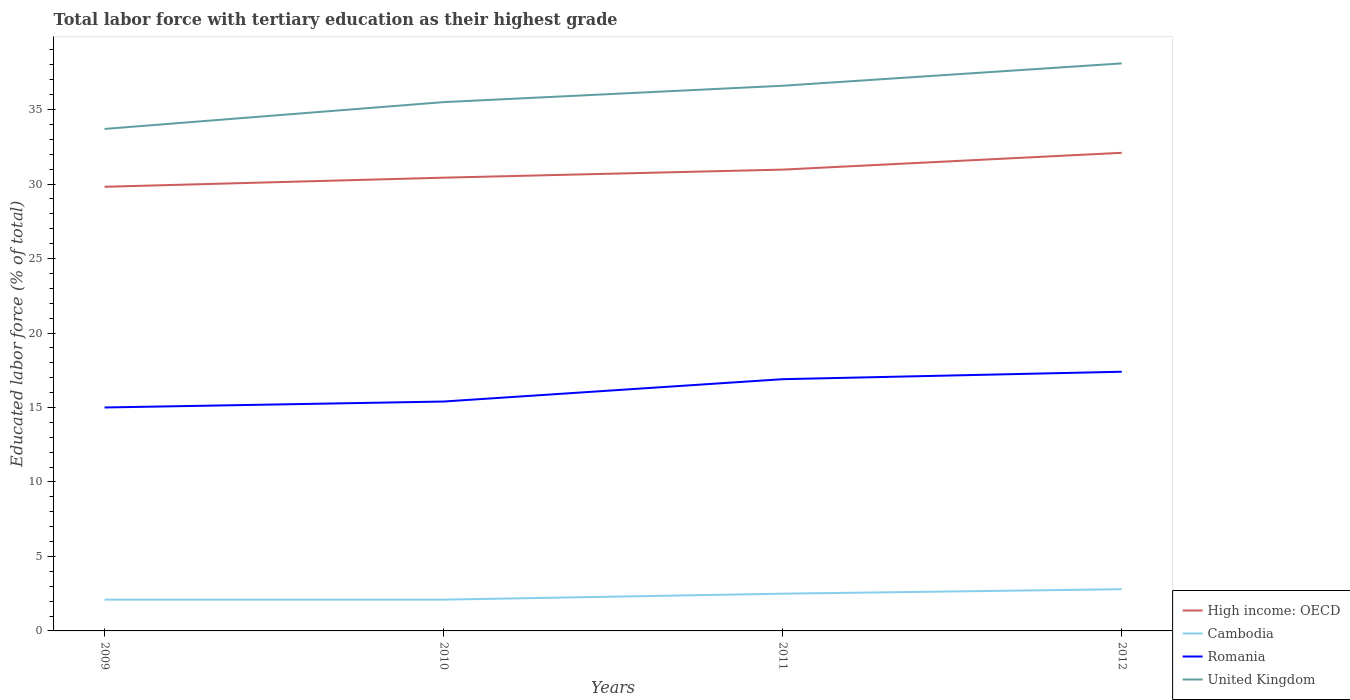Is the number of lines equal to the number of legend labels?
Offer a terse response. Yes. In which year was the percentage of male labor force with tertiary education in Romania maximum?
Your answer should be very brief. 2009. What is the total percentage of male labor force with tertiary education in Romania in the graph?
Your response must be concise. -0.4. What is the difference between the highest and the second highest percentage of male labor force with tertiary education in United Kingdom?
Offer a terse response. 4.4. Is the percentage of male labor force with tertiary education in Romania strictly greater than the percentage of male labor force with tertiary education in High income: OECD over the years?
Your answer should be very brief. Yes. How many years are there in the graph?
Give a very brief answer. 4. Are the values on the major ticks of Y-axis written in scientific E-notation?
Ensure brevity in your answer.  No. Does the graph contain any zero values?
Keep it short and to the point. No. Does the graph contain grids?
Offer a very short reply. No. What is the title of the graph?
Your response must be concise. Total labor force with tertiary education as their highest grade. What is the label or title of the X-axis?
Give a very brief answer. Years. What is the label or title of the Y-axis?
Offer a terse response. Educated labor force (% of total). What is the Educated labor force (% of total) of High income: OECD in 2009?
Make the answer very short. 29.82. What is the Educated labor force (% of total) in Cambodia in 2009?
Your answer should be compact. 2.1. What is the Educated labor force (% of total) of United Kingdom in 2009?
Ensure brevity in your answer.  33.7. What is the Educated labor force (% of total) of High income: OECD in 2010?
Give a very brief answer. 30.43. What is the Educated labor force (% of total) in Cambodia in 2010?
Provide a succinct answer. 2.1. What is the Educated labor force (% of total) of Romania in 2010?
Ensure brevity in your answer.  15.4. What is the Educated labor force (% of total) of United Kingdom in 2010?
Provide a succinct answer. 35.5. What is the Educated labor force (% of total) of High income: OECD in 2011?
Keep it short and to the point. 30.97. What is the Educated labor force (% of total) of Cambodia in 2011?
Offer a very short reply. 2.5. What is the Educated labor force (% of total) of Romania in 2011?
Provide a succinct answer. 16.9. What is the Educated labor force (% of total) of United Kingdom in 2011?
Offer a terse response. 36.6. What is the Educated labor force (% of total) of High income: OECD in 2012?
Your answer should be compact. 32.1. What is the Educated labor force (% of total) of Cambodia in 2012?
Your answer should be compact. 2.8. What is the Educated labor force (% of total) of Romania in 2012?
Give a very brief answer. 17.4. What is the Educated labor force (% of total) of United Kingdom in 2012?
Your answer should be very brief. 38.1. Across all years, what is the maximum Educated labor force (% of total) of High income: OECD?
Your answer should be very brief. 32.1. Across all years, what is the maximum Educated labor force (% of total) of Cambodia?
Offer a very short reply. 2.8. Across all years, what is the maximum Educated labor force (% of total) of Romania?
Your response must be concise. 17.4. Across all years, what is the maximum Educated labor force (% of total) in United Kingdom?
Provide a short and direct response. 38.1. Across all years, what is the minimum Educated labor force (% of total) of High income: OECD?
Your answer should be very brief. 29.82. Across all years, what is the minimum Educated labor force (% of total) of Cambodia?
Give a very brief answer. 2.1. Across all years, what is the minimum Educated labor force (% of total) in Romania?
Your answer should be compact. 15. Across all years, what is the minimum Educated labor force (% of total) of United Kingdom?
Provide a succinct answer. 33.7. What is the total Educated labor force (% of total) of High income: OECD in the graph?
Make the answer very short. 123.31. What is the total Educated labor force (% of total) of Romania in the graph?
Provide a succinct answer. 64.7. What is the total Educated labor force (% of total) in United Kingdom in the graph?
Make the answer very short. 143.9. What is the difference between the Educated labor force (% of total) of High income: OECD in 2009 and that in 2010?
Make the answer very short. -0.61. What is the difference between the Educated labor force (% of total) of Romania in 2009 and that in 2010?
Your answer should be compact. -0.4. What is the difference between the Educated labor force (% of total) of High income: OECD in 2009 and that in 2011?
Your answer should be compact. -1.15. What is the difference between the Educated labor force (% of total) in Cambodia in 2009 and that in 2011?
Give a very brief answer. -0.4. What is the difference between the Educated labor force (% of total) of Romania in 2009 and that in 2011?
Offer a very short reply. -1.9. What is the difference between the Educated labor force (% of total) in United Kingdom in 2009 and that in 2011?
Make the answer very short. -2.9. What is the difference between the Educated labor force (% of total) in High income: OECD in 2009 and that in 2012?
Give a very brief answer. -2.28. What is the difference between the Educated labor force (% of total) in Cambodia in 2009 and that in 2012?
Ensure brevity in your answer.  -0.7. What is the difference between the Educated labor force (% of total) in High income: OECD in 2010 and that in 2011?
Your answer should be compact. -0.54. What is the difference between the Educated labor force (% of total) in Cambodia in 2010 and that in 2011?
Provide a succinct answer. -0.4. What is the difference between the Educated labor force (% of total) of United Kingdom in 2010 and that in 2011?
Keep it short and to the point. -1.1. What is the difference between the Educated labor force (% of total) of High income: OECD in 2010 and that in 2012?
Offer a terse response. -1.67. What is the difference between the Educated labor force (% of total) in Cambodia in 2010 and that in 2012?
Offer a terse response. -0.7. What is the difference between the Educated labor force (% of total) in United Kingdom in 2010 and that in 2012?
Your answer should be compact. -2.6. What is the difference between the Educated labor force (% of total) in High income: OECD in 2011 and that in 2012?
Provide a succinct answer. -1.13. What is the difference between the Educated labor force (% of total) in High income: OECD in 2009 and the Educated labor force (% of total) in Cambodia in 2010?
Give a very brief answer. 27.72. What is the difference between the Educated labor force (% of total) in High income: OECD in 2009 and the Educated labor force (% of total) in Romania in 2010?
Your answer should be compact. 14.42. What is the difference between the Educated labor force (% of total) in High income: OECD in 2009 and the Educated labor force (% of total) in United Kingdom in 2010?
Your answer should be compact. -5.68. What is the difference between the Educated labor force (% of total) of Cambodia in 2009 and the Educated labor force (% of total) of Romania in 2010?
Your answer should be very brief. -13.3. What is the difference between the Educated labor force (% of total) in Cambodia in 2009 and the Educated labor force (% of total) in United Kingdom in 2010?
Your response must be concise. -33.4. What is the difference between the Educated labor force (% of total) in Romania in 2009 and the Educated labor force (% of total) in United Kingdom in 2010?
Provide a short and direct response. -20.5. What is the difference between the Educated labor force (% of total) of High income: OECD in 2009 and the Educated labor force (% of total) of Cambodia in 2011?
Give a very brief answer. 27.32. What is the difference between the Educated labor force (% of total) of High income: OECD in 2009 and the Educated labor force (% of total) of Romania in 2011?
Make the answer very short. 12.92. What is the difference between the Educated labor force (% of total) of High income: OECD in 2009 and the Educated labor force (% of total) of United Kingdom in 2011?
Provide a short and direct response. -6.78. What is the difference between the Educated labor force (% of total) in Cambodia in 2009 and the Educated labor force (% of total) in Romania in 2011?
Your answer should be compact. -14.8. What is the difference between the Educated labor force (% of total) in Cambodia in 2009 and the Educated labor force (% of total) in United Kingdom in 2011?
Offer a terse response. -34.5. What is the difference between the Educated labor force (% of total) in Romania in 2009 and the Educated labor force (% of total) in United Kingdom in 2011?
Offer a very short reply. -21.6. What is the difference between the Educated labor force (% of total) of High income: OECD in 2009 and the Educated labor force (% of total) of Cambodia in 2012?
Provide a short and direct response. 27.02. What is the difference between the Educated labor force (% of total) of High income: OECD in 2009 and the Educated labor force (% of total) of Romania in 2012?
Give a very brief answer. 12.42. What is the difference between the Educated labor force (% of total) in High income: OECD in 2009 and the Educated labor force (% of total) in United Kingdom in 2012?
Provide a short and direct response. -8.28. What is the difference between the Educated labor force (% of total) of Cambodia in 2009 and the Educated labor force (% of total) of Romania in 2012?
Your answer should be very brief. -15.3. What is the difference between the Educated labor force (% of total) in Cambodia in 2009 and the Educated labor force (% of total) in United Kingdom in 2012?
Make the answer very short. -36. What is the difference between the Educated labor force (% of total) in Romania in 2009 and the Educated labor force (% of total) in United Kingdom in 2012?
Your answer should be very brief. -23.1. What is the difference between the Educated labor force (% of total) of High income: OECD in 2010 and the Educated labor force (% of total) of Cambodia in 2011?
Your answer should be compact. 27.93. What is the difference between the Educated labor force (% of total) in High income: OECD in 2010 and the Educated labor force (% of total) in Romania in 2011?
Provide a short and direct response. 13.53. What is the difference between the Educated labor force (% of total) in High income: OECD in 2010 and the Educated labor force (% of total) in United Kingdom in 2011?
Keep it short and to the point. -6.17. What is the difference between the Educated labor force (% of total) of Cambodia in 2010 and the Educated labor force (% of total) of Romania in 2011?
Keep it short and to the point. -14.8. What is the difference between the Educated labor force (% of total) of Cambodia in 2010 and the Educated labor force (% of total) of United Kingdom in 2011?
Offer a very short reply. -34.5. What is the difference between the Educated labor force (% of total) in Romania in 2010 and the Educated labor force (% of total) in United Kingdom in 2011?
Your response must be concise. -21.2. What is the difference between the Educated labor force (% of total) of High income: OECD in 2010 and the Educated labor force (% of total) of Cambodia in 2012?
Ensure brevity in your answer.  27.63. What is the difference between the Educated labor force (% of total) in High income: OECD in 2010 and the Educated labor force (% of total) in Romania in 2012?
Ensure brevity in your answer.  13.03. What is the difference between the Educated labor force (% of total) in High income: OECD in 2010 and the Educated labor force (% of total) in United Kingdom in 2012?
Offer a terse response. -7.67. What is the difference between the Educated labor force (% of total) in Cambodia in 2010 and the Educated labor force (% of total) in Romania in 2012?
Your answer should be compact. -15.3. What is the difference between the Educated labor force (% of total) of Cambodia in 2010 and the Educated labor force (% of total) of United Kingdom in 2012?
Offer a very short reply. -36. What is the difference between the Educated labor force (% of total) in Romania in 2010 and the Educated labor force (% of total) in United Kingdom in 2012?
Give a very brief answer. -22.7. What is the difference between the Educated labor force (% of total) of High income: OECD in 2011 and the Educated labor force (% of total) of Cambodia in 2012?
Provide a succinct answer. 28.17. What is the difference between the Educated labor force (% of total) in High income: OECD in 2011 and the Educated labor force (% of total) in Romania in 2012?
Keep it short and to the point. 13.57. What is the difference between the Educated labor force (% of total) of High income: OECD in 2011 and the Educated labor force (% of total) of United Kingdom in 2012?
Keep it short and to the point. -7.13. What is the difference between the Educated labor force (% of total) in Cambodia in 2011 and the Educated labor force (% of total) in Romania in 2012?
Give a very brief answer. -14.9. What is the difference between the Educated labor force (% of total) of Cambodia in 2011 and the Educated labor force (% of total) of United Kingdom in 2012?
Your response must be concise. -35.6. What is the difference between the Educated labor force (% of total) in Romania in 2011 and the Educated labor force (% of total) in United Kingdom in 2012?
Your answer should be compact. -21.2. What is the average Educated labor force (% of total) of High income: OECD per year?
Keep it short and to the point. 30.83. What is the average Educated labor force (% of total) in Cambodia per year?
Your answer should be very brief. 2.38. What is the average Educated labor force (% of total) in Romania per year?
Ensure brevity in your answer.  16.18. What is the average Educated labor force (% of total) in United Kingdom per year?
Make the answer very short. 35.98. In the year 2009, what is the difference between the Educated labor force (% of total) of High income: OECD and Educated labor force (% of total) of Cambodia?
Make the answer very short. 27.72. In the year 2009, what is the difference between the Educated labor force (% of total) of High income: OECD and Educated labor force (% of total) of Romania?
Your answer should be very brief. 14.82. In the year 2009, what is the difference between the Educated labor force (% of total) in High income: OECD and Educated labor force (% of total) in United Kingdom?
Keep it short and to the point. -3.88. In the year 2009, what is the difference between the Educated labor force (% of total) of Cambodia and Educated labor force (% of total) of United Kingdom?
Provide a succinct answer. -31.6. In the year 2009, what is the difference between the Educated labor force (% of total) of Romania and Educated labor force (% of total) of United Kingdom?
Make the answer very short. -18.7. In the year 2010, what is the difference between the Educated labor force (% of total) of High income: OECD and Educated labor force (% of total) of Cambodia?
Make the answer very short. 28.33. In the year 2010, what is the difference between the Educated labor force (% of total) in High income: OECD and Educated labor force (% of total) in Romania?
Keep it short and to the point. 15.03. In the year 2010, what is the difference between the Educated labor force (% of total) of High income: OECD and Educated labor force (% of total) of United Kingdom?
Your answer should be very brief. -5.07. In the year 2010, what is the difference between the Educated labor force (% of total) in Cambodia and Educated labor force (% of total) in Romania?
Give a very brief answer. -13.3. In the year 2010, what is the difference between the Educated labor force (% of total) of Cambodia and Educated labor force (% of total) of United Kingdom?
Make the answer very short. -33.4. In the year 2010, what is the difference between the Educated labor force (% of total) in Romania and Educated labor force (% of total) in United Kingdom?
Offer a terse response. -20.1. In the year 2011, what is the difference between the Educated labor force (% of total) in High income: OECD and Educated labor force (% of total) in Cambodia?
Offer a terse response. 28.47. In the year 2011, what is the difference between the Educated labor force (% of total) in High income: OECD and Educated labor force (% of total) in Romania?
Make the answer very short. 14.07. In the year 2011, what is the difference between the Educated labor force (% of total) in High income: OECD and Educated labor force (% of total) in United Kingdom?
Make the answer very short. -5.63. In the year 2011, what is the difference between the Educated labor force (% of total) of Cambodia and Educated labor force (% of total) of Romania?
Make the answer very short. -14.4. In the year 2011, what is the difference between the Educated labor force (% of total) in Cambodia and Educated labor force (% of total) in United Kingdom?
Offer a very short reply. -34.1. In the year 2011, what is the difference between the Educated labor force (% of total) of Romania and Educated labor force (% of total) of United Kingdom?
Ensure brevity in your answer.  -19.7. In the year 2012, what is the difference between the Educated labor force (% of total) of High income: OECD and Educated labor force (% of total) of Cambodia?
Your response must be concise. 29.3. In the year 2012, what is the difference between the Educated labor force (% of total) of High income: OECD and Educated labor force (% of total) of Romania?
Ensure brevity in your answer.  14.7. In the year 2012, what is the difference between the Educated labor force (% of total) in High income: OECD and Educated labor force (% of total) in United Kingdom?
Your answer should be compact. -6. In the year 2012, what is the difference between the Educated labor force (% of total) of Cambodia and Educated labor force (% of total) of Romania?
Provide a short and direct response. -14.6. In the year 2012, what is the difference between the Educated labor force (% of total) in Cambodia and Educated labor force (% of total) in United Kingdom?
Give a very brief answer. -35.3. In the year 2012, what is the difference between the Educated labor force (% of total) in Romania and Educated labor force (% of total) in United Kingdom?
Your response must be concise. -20.7. What is the ratio of the Educated labor force (% of total) of High income: OECD in 2009 to that in 2010?
Your answer should be compact. 0.98. What is the ratio of the Educated labor force (% of total) in United Kingdom in 2009 to that in 2010?
Your answer should be very brief. 0.95. What is the ratio of the Educated labor force (% of total) of High income: OECD in 2009 to that in 2011?
Offer a very short reply. 0.96. What is the ratio of the Educated labor force (% of total) in Cambodia in 2009 to that in 2011?
Offer a terse response. 0.84. What is the ratio of the Educated labor force (% of total) of Romania in 2009 to that in 2011?
Provide a succinct answer. 0.89. What is the ratio of the Educated labor force (% of total) in United Kingdom in 2009 to that in 2011?
Offer a very short reply. 0.92. What is the ratio of the Educated labor force (% of total) of High income: OECD in 2009 to that in 2012?
Offer a very short reply. 0.93. What is the ratio of the Educated labor force (% of total) of Romania in 2009 to that in 2012?
Offer a very short reply. 0.86. What is the ratio of the Educated labor force (% of total) of United Kingdom in 2009 to that in 2012?
Provide a short and direct response. 0.88. What is the ratio of the Educated labor force (% of total) of High income: OECD in 2010 to that in 2011?
Ensure brevity in your answer.  0.98. What is the ratio of the Educated labor force (% of total) in Cambodia in 2010 to that in 2011?
Offer a very short reply. 0.84. What is the ratio of the Educated labor force (% of total) in Romania in 2010 to that in 2011?
Make the answer very short. 0.91. What is the ratio of the Educated labor force (% of total) in United Kingdom in 2010 to that in 2011?
Your answer should be compact. 0.97. What is the ratio of the Educated labor force (% of total) of High income: OECD in 2010 to that in 2012?
Offer a terse response. 0.95. What is the ratio of the Educated labor force (% of total) in Cambodia in 2010 to that in 2012?
Offer a very short reply. 0.75. What is the ratio of the Educated labor force (% of total) in Romania in 2010 to that in 2012?
Offer a very short reply. 0.89. What is the ratio of the Educated labor force (% of total) in United Kingdom in 2010 to that in 2012?
Your response must be concise. 0.93. What is the ratio of the Educated labor force (% of total) in High income: OECD in 2011 to that in 2012?
Offer a very short reply. 0.96. What is the ratio of the Educated labor force (% of total) of Cambodia in 2011 to that in 2012?
Ensure brevity in your answer.  0.89. What is the ratio of the Educated labor force (% of total) of Romania in 2011 to that in 2012?
Keep it short and to the point. 0.97. What is the ratio of the Educated labor force (% of total) in United Kingdom in 2011 to that in 2012?
Offer a terse response. 0.96. What is the difference between the highest and the second highest Educated labor force (% of total) of High income: OECD?
Provide a short and direct response. 1.13. What is the difference between the highest and the second highest Educated labor force (% of total) of United Kingdom?
Make the answer very short. 1.5. What is the difference between the highest and the lowest Educated labor force (% of total) in High income: OECD?
Ensure brevity in your answer.  2.28. What is the difference between the highest and the lowest Educated labor force (% of total) in Romania?
Offer a very short reply. 2.4. What is the difference between the highest and the lowest Educated labor force (% of total) in United Kingdom?
Ensure brevity in your answer.  4.4. 